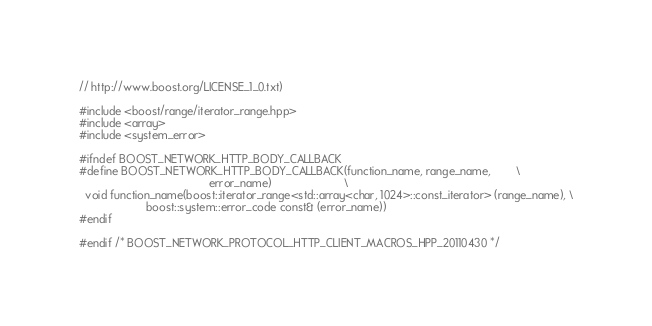Convert code to text. <code><loc_0><loc_0><loc_500><loc_500><_C++_>// http://www.boost.org/LICENSE_1_0.txt)

#include <boost/range/iterator_range.hpp>
#include <array>
#include <system_error>

#ifndef BOOST_NETWORK_HTTP_BODY_CALLBACK
#define BOOST_NETWORK_HTTP_BODY_CALLBACK(function_name, range_name,        \
                                         error_name)                       \
  void function_name(boost::iterator_range<std::array<char, 1024>::const_iterator> (range_name), \
                     boost::system::error_code const& (error_name))
#endif

#endif /* BOOST_NETWORK_PROTOCOL_HTTP_CLIENT_MACROS_HPP_20110430 */
</code> 